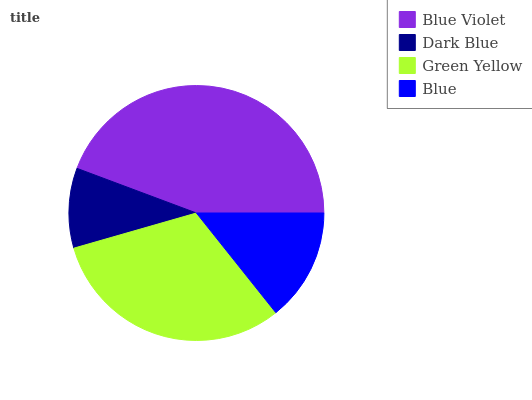Is Dark Blue the minimum?
Answer yes or no. Yes. Is Blue Violet the maximum?
Answer yes or no. Yes. Is Green Yellow the minimum?
Answer yes or no. No. Is Green Yellow the maximum?
Answer yes or no. No. Is Green Yellow greater than Dark Blue?
Answer yes or no. Yes. Is Dark Blue less than Green Yellow?
Answer yes or no. Yes. Is Dark Blue greater than Green Yellow?
Answer yes or no. No. Is Green Yellow less than Dark Blue?
Answer yes or no. No. Is Green Yellow the high median?
Answer yes or no. Yes. Is Blue the low median?
Answer yes or no. Yes. Is Dark Blue the high median?
Answer yes or no. No. Is Green Yellow the low median?
Answer yes or no. No. 